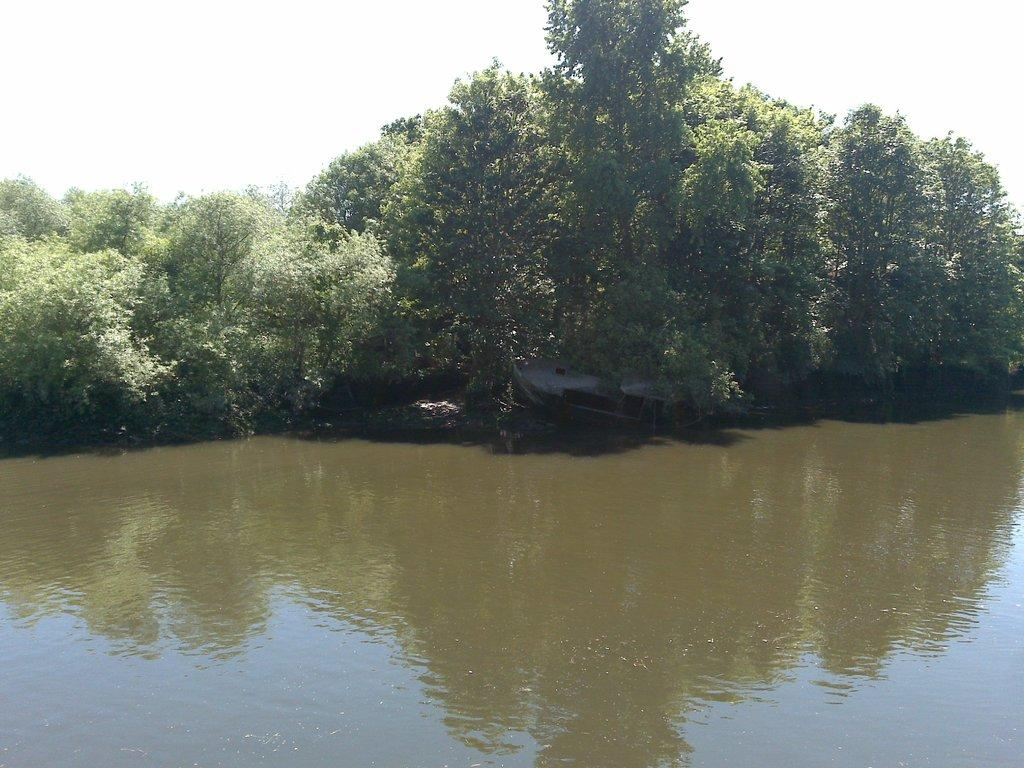What is the primary element visible in the image? There is water in the image. What can be seen in the distance in the image? There are trees in the background of the image. What type of letters are being cut with scissors in the image? There are no letters or scissors present in the image. 